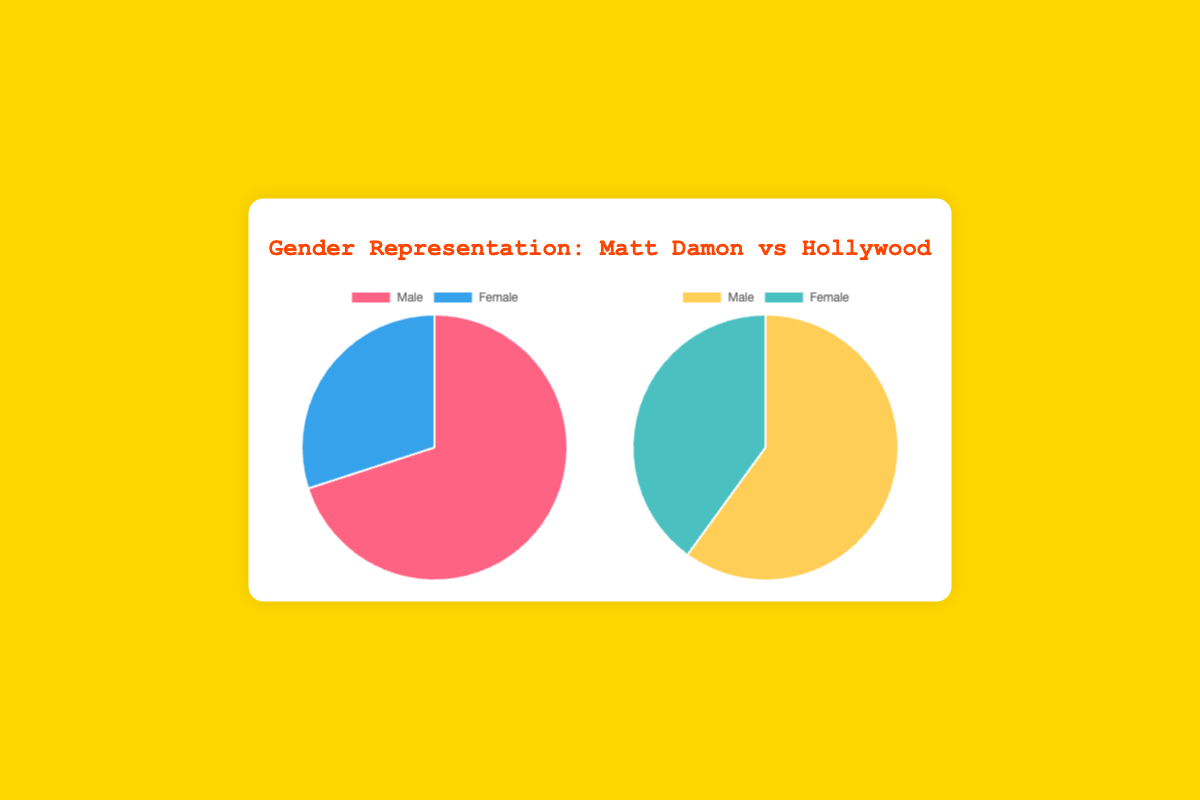What is the proportion of male representation in the main cast of Matt Damon Films? The pie chart for Matt Damon Films shows that male representation is 70%.
Answer: 70% How does female representation in Matt Damon Films compare to General Hollywood Films? From the pie charts, female representation in Matt Damon Films is 30%, whereas it is 40% in General Hollywood Films.
Answer: 30% vs 40% Which has a higher percentage of male representation, Matt Damon Films or General Hollywood Films? The pie chart shows that Matt Damon Films have 70% male representation, while General Hollywood Films have 60% male representation, so Matt Damon Films have a higher percentage.
Answer: Matt Damon Films What is the difference in female representation between General Hollywood Films and Matt Damon Films? The pie chart indicates that female representation in General Hollywood Films is 40%, and in Matt Damon Films, it is 30%. The difference is 40% - 30% = 10%.
Answer: 10% Out of 100%, how much greater is the male representation in Matt Damon Films compared to General Hollywood Films? Male representation is 70% in Matt Damon Films and 60% in General Hollywood Films, so 70% - 60% = 10% greater.
Answer: 10% What is the combined female representation percentage in both Matt Damon Films and General Hollywood Films? The female representation is 30% in Matt Damon Films and 40% in General Hollywood Films. The sum is 30% + 40% = 70%.
Answer: 70% If the total representation is 100%, what is the total male representation percentage in both types of films? The total male representation would be the sum of male percentages in both types of films: 70% (Matt Damon Films) + 60% (General Hollywood Films) = 130%.
Answer: 130% What is the average female representation percentage in Matt Damon Films and General Hollywood Films? Add the female percentages of both: 30% (Matt Damon Films) + 40% (General Hollywood Films) = 70%. Divide by 2 to get the average: 70% / 2 = 35%.
Answer: 35% 